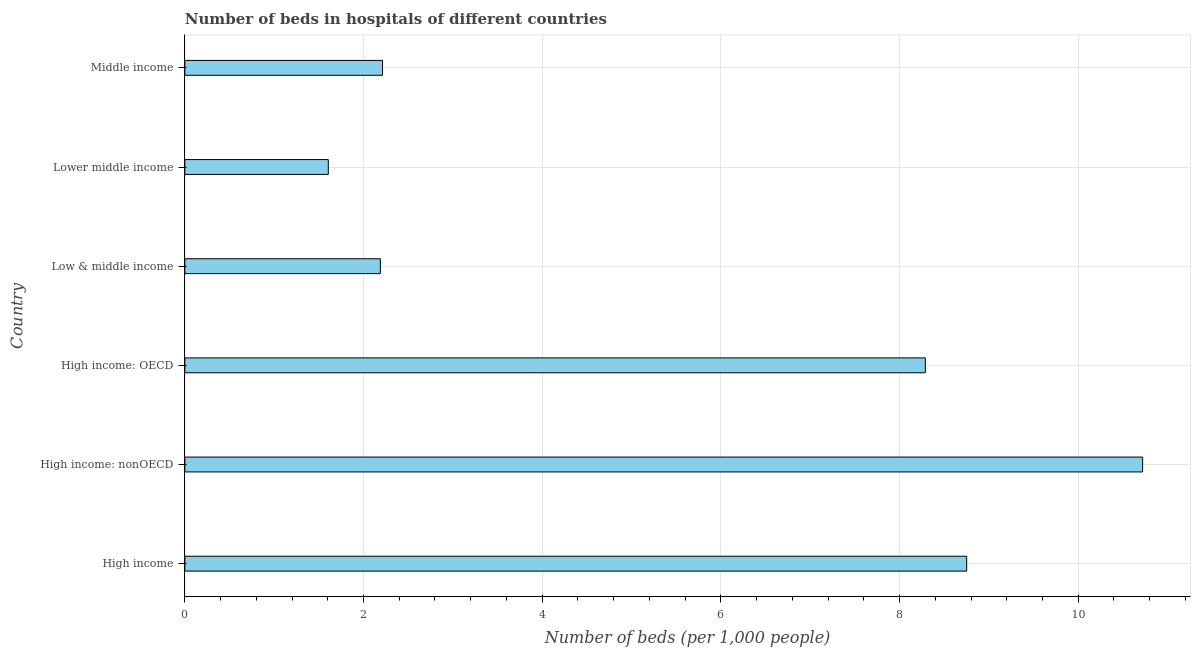Does the graph contain any zero values?
Provide a short and direct response. No. What is the title of the graph?
Provide a succinct answer. Number of beds in hospitals of different countries. What is the label or title of the X-axis?
Provide a succinct answer. Number of beds (per 1,0 people). What is the label or title of the Y-axis?
Offer a terse response. Country. What is the number of hospital beds in Lower middle income?
Offer a terse response. 1.61. Across all countries, what is the maximum number of hospital beds?
Your response must be concise. 10.72. Across all countries, what is the minimum number of hospital beds?
Make the answer very short. 1.61. In which country was the number of hospital beds maximum?
Provide a short and direct response. High income: nonOECD. In which country was the number of hospital beds minimum?
Ensure brevity in your answer.  Lower middle income. What is the sum of the number of hospital beds?
Your answer should be very brief. 33.77. What is the difference between the number of hospital beds in High income and Low & middle income?
Ensure brevity in your answer.  6.56. What is the average number of hospital beds per country?
Ensure brevity in your answer.  5.63. What is the median number of hospital beds?
Your response must be concise. 5.25. What is the difference between the highest and the second highest number of hospital beds?
Your answer should be compact. 1.97. Is the sum of the number of hospital beds in Low & middle income and Middle income greater than the maximum number of hospital beds across all countries?
Provide a succinct answer. No. What is the difference between the highest and the lowest number of hospital beds?
Provide a succinct answer. 9.11. In how many countries, is the number of hospital beds greater than the average number of hospital beds taken over all countries?
Keep it short and to the point. 3. Are the values on the major ticks of X-axis written in scientific E-notation?
Ensure brevity in your answer.  No. What is the Number of beds (per 1,000 people) in High income?
Ensure brevity in your answer.  8.75. What is the Number of beds (per 1,000 people) of High income: nonOECD?
Offer a terse response. 10.72. What is the Number of beds (per 1,000 people) of High income: OECD?
Ensure brevity in your answer.  8.29. What is the Number of beds (per 1,000 people) of Low & middle income?
Provide a succinct answer. 2.19. What is the Number of beds (per 1,000 people) in Lower middle income?
Provide a short and direct response. 1.61. What is the Number of beds (per 1,000 people) in Middle income?
Offer a very short reply. 2.21. What is the difference between the Number of beds (per 1,000 people) in High income and High income: nonOECD?
Provide a short and direct response. -1.97. What is the difference between the Number of beds (per 1,000 people) in High income and High income: OECD?
Offer a terse response. 0.46. What is the difference between the Number of beds (per 1,000 people) in High income and Low & middle income?
Make the answer very short. 6.56. What is the difference between the Number of beds (per 1,000 people) in High income and Lower middle income?
Your answer should be compact. 7.15. What is the difference between the Number of beds (per 1,000 people) in High income and Middle income?
Your answer should be very brief. 6.54. What is the difference between the Number of beds (per 1,000 people) in High income: nonOECD and High income: OECD?
Provide a succinct answer. 2.43. What is the difference between the Number of beds (per 1,000 people) in High income: nonOECD and Low & middle income?
Provide a succinct answer. 8.53. What is the difference between the Number of beds (per 1,000 people) in High income: nonOECD and Lower middle income?
Your response must be concise. 9.11. What is the difference between the Number of beds (per 1,000 people) in High income: nonOECD and Middle income?
Keep it short and to the point. 8.51. What is the difference between the Number of beds (per 1,000 people) in High income: OECD and Low & middle income?
Keep it short and to the point. 6.1. What is the difference between the Number of beds (per 1,000 people) in High income: OECD and Lower middle income?
Make the answer very short. 6.68. What is the difference between the Number of beds (per 1,000 people) in High income: OECD and Middle income?
Your answer should be very brief. 6.08. What is the difference between the Number of beds (per 1,000 people) in Low & middle income and Lower middle income?
Provide a succinct answer. 0.58. What is the difference between the Number of beds (per 1,000 people) in Low & middle income and Middle income?
Provide a short and direct response. -0.02. What is the difference between the Number of beds (per 1,000 people) in Lower middle income and Middle income?
Make the answer very short. -0.61. What is the ratio of the Number of beds (per 1,000 people) in High income to that in High income: nonOECD?
Provide a short and direct response. 0.82. What is the ratio of the Number of beds (per 1,000 people) in High income to that in High income: OECD?
Offer a terse response. 1.06. What is the ratio of the Number of beds (per 1,000 people) in High income to that in Low & middle income?
Offer a terse response. 4. What is the ratio of the Number of beds (per 1,000 people) in High income to that in Lower middle income?
Your response must be concise. 5.45. What is the ratio of the Number of beds (per 1,000 people) in High income to that in Middle income?
Give a very brief answer. 3.96. What is the ratio of the Number of beds (per 1,000 people) in High income: nonOECD to that in High income: OECD?
Your response must be concise. 1.29. What is the ratio of the Number of beds (per 1,000 people) in High income: nonOECD to that in Low & middle income?
Keep it short and to the point. 4.9. What is the ratio of the Number of beds (per 1,000 people) in High income: nonOECD to that in Lower middle income?
Keep it short and to the point. 6.67. What is the ratio of the Number of beds (per 1,000 people) in High income: nonOECD to that in Middle income?
Provide a short and direct response. 4.85. What is the ratio of the Number of beds (per 1,000 people) in High income: OECD to that in Low & middle income?
Keep it short and to the point. 3.79. What is the ratio of the Number of beds (per 1,000 people) in High income: OECD to that in Lower middle income?
Your answer should be very brief. 5.16. What is the ratio of the Number of beds (per 1,000 people) in High income: OECD to that in Middle income?
Your answer should be very brief. 3.75. What is the ratio of the Number of beds (per 1,000 people) in Low & middle income to that in Lower middle income?
Your answer should be very brief. 1.36. What is the ratio of the Number of beds (per 1,000 people) in Low & middle income to that in Middle income?
Your answer should be compact. 0.99. What is the ratio of the Number of beds (per 1,000 people) in Lower middle income to that in Middle income?
Provide a succinct answer. 0.73. 